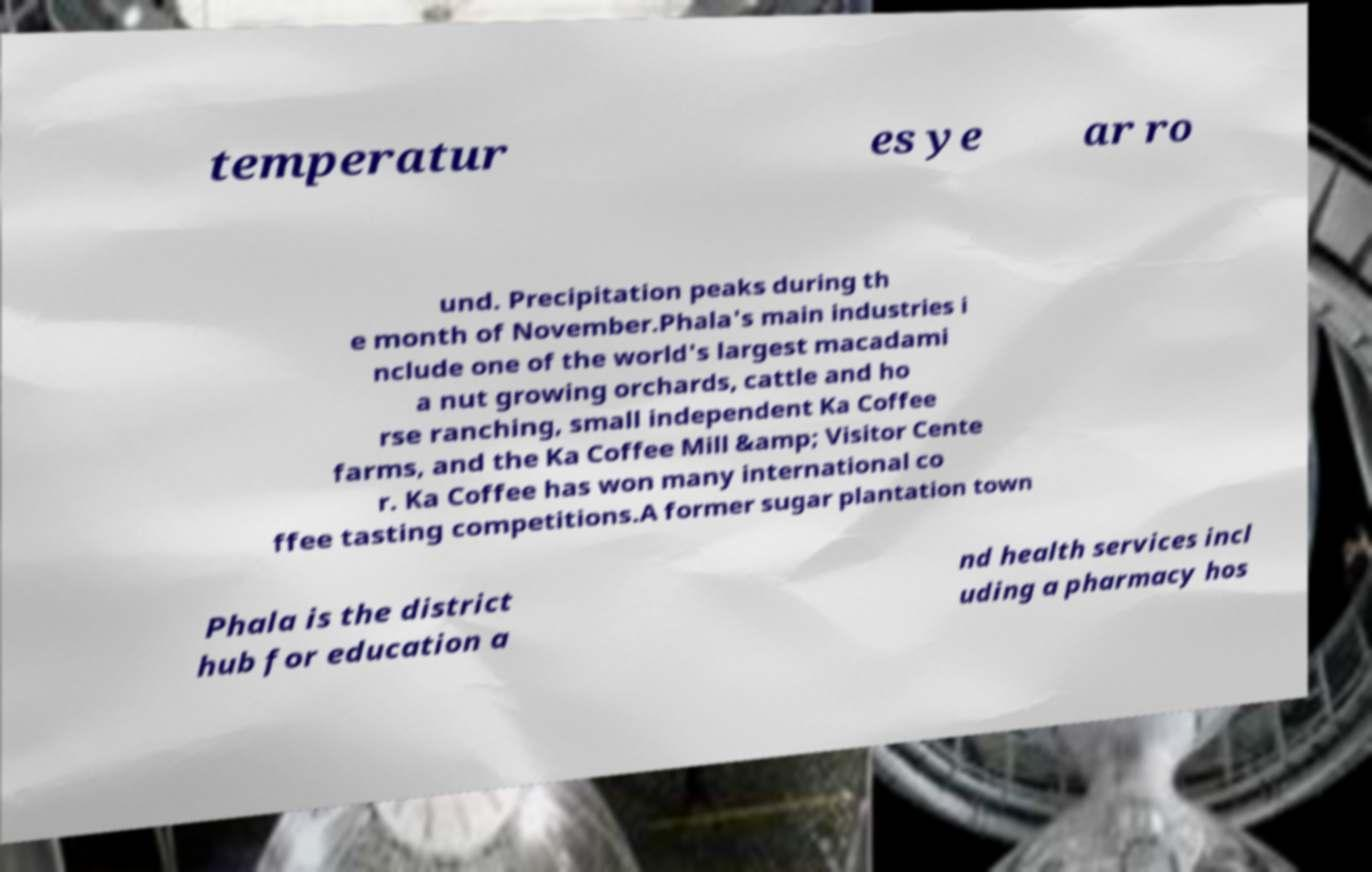For documentation purposes, I need the text within this image transcribed. Could you provide that? temperatur es ye ar ro und. Precipitation peaks during th e month of November.Phala's main industries i nclude one of the world's largest macadami a nut growing orchards, cattle and ho rse ranching, small independent Ka Coffee farms, and the Ka Coffee Mill &amp; Visitor Cente r. Ka Coffee has won many international co ffee tasting competitions.A former sugar plantation town Phala is the district hub for education a nd health services incl uding a pharmacy hos 